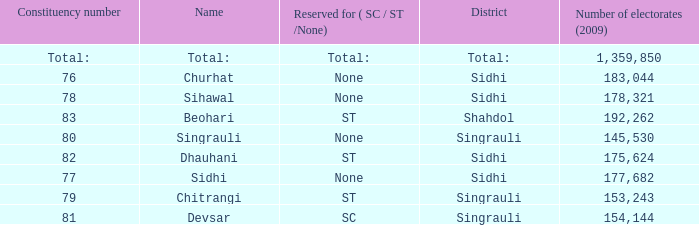What is Beohari's highest number of electorates? 192262.0. 